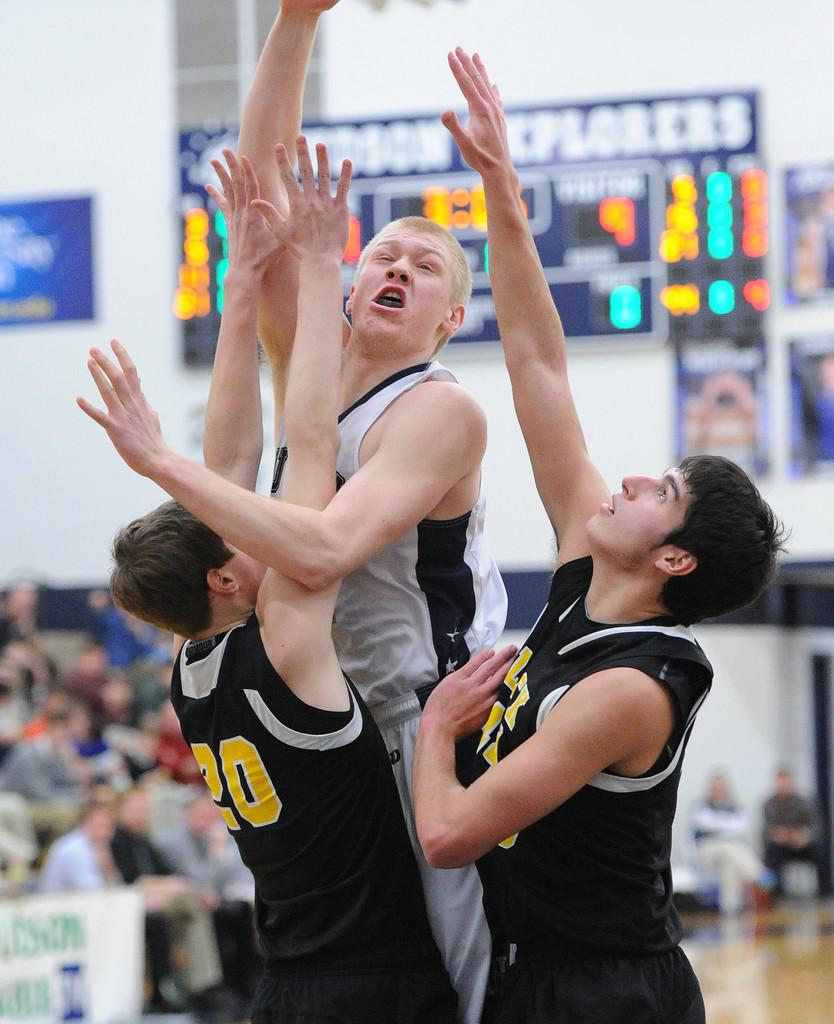What is there are people in the image, where are they located? There are persons in the center of the image. What can be seen in the background of the image? There is a crowd and a screen in the image. What type of shade is being used to cover the scene in the image? There is no shade present in the image; it features persons in the center, a crowd, and a screen in the background. 